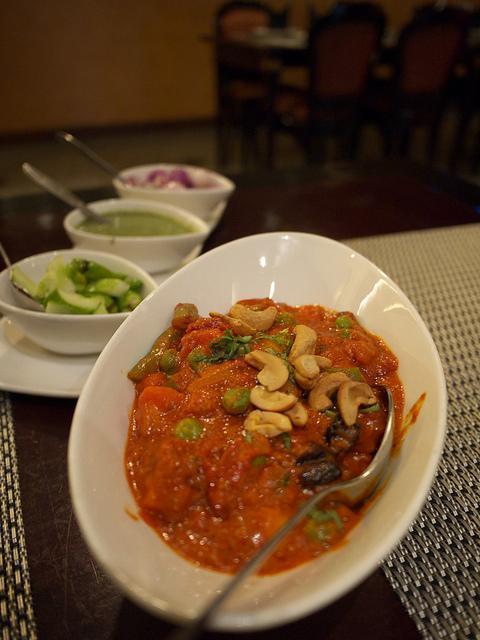What fungal growth is visible here?
Make your selection from the four choices given to correctly answer the question.
Options: Tomatoes, mushrooms, cucumbers, olives. Mushrooms. 